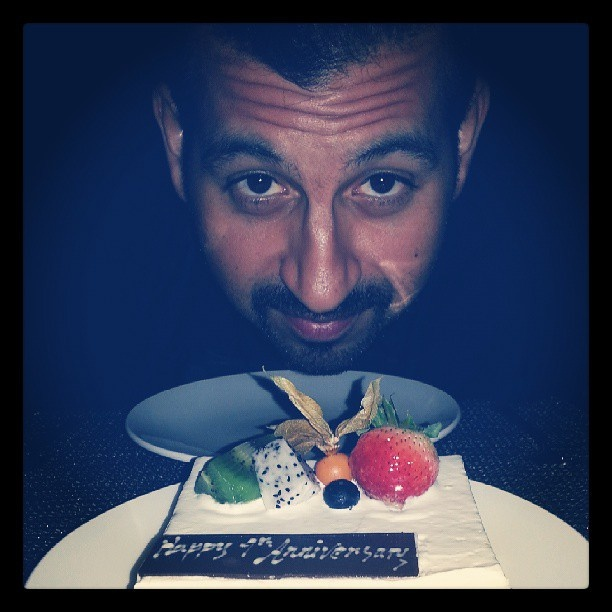Describe the objects in this image and their specific colors. I can see people in black, navy, purple, and gray tones, cake in black, beige, navy, lightgray, and darkgray tones, and bowl in black, gray, blue, and navy tones in this image. 